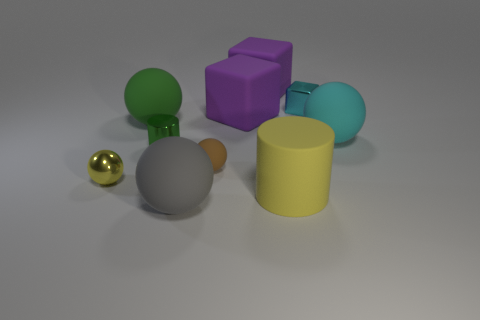Subtract 1 spheres. How many spheres are left? 4 Subtract all yellow spheres. How many spheres are left? 4 Subtract all yellow balls. How many balls are left? 4 Subtract all green cylinders. Subtract all gray cubes. How many cylinders are left? 1 Subtract all cubes. How many objects are left? 7 Add 1 tiny blue things. How many tiny blue things exist? 1 Subtract 1 yellow cylinders. How many objects are left? 9 Subtract all purple matte blocks. Subtract all large purple things. How many objects are left? 6 Add 2 gray balls. How many gray balls are left? 3 